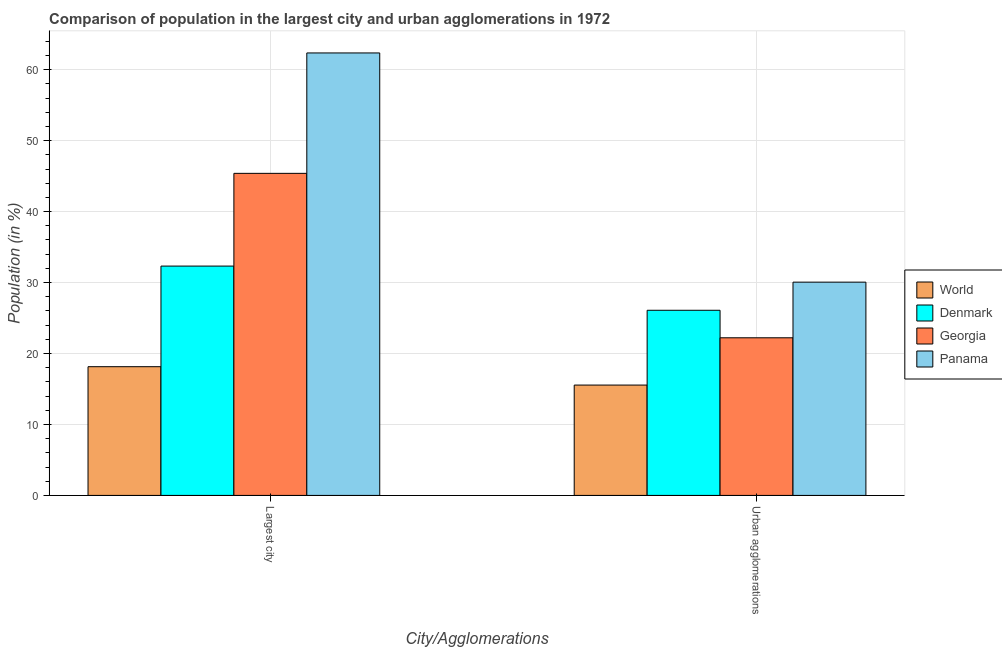How many different coloured bars are there?
Make the answer very short. 4. Are the number of bars on each tick of the X-axis equal?
Keep it short and to the point. Yes. How many bars are there on the 2nd tick from the left?
Offer a terse response. 4. What is the label of the 2nd group of bars from the left?
Your answer should be very brief. Urban agglomerations. What is the population in urban agglomerations in Denmark?
Keep it short and to the point. 26.09. Across all countries, what is the maximum population in the largest city?
Offer a very short reply. 62.36. Across all countries, what is the minimum population in urban agglomerations?
Provide a succinct answer. 15.55. In which country was the population in the largest city maximum?
Keep it short and to the point. Panama. In which country was the population in urban agglomerations minimum?
Give a very brief answer. World. What is the total population in urban agglomerations in the graph?
Your response must be concise. 93.92. What is the difference between the population in the largest city in Panama and that in World?
Give a very brief answer. 44.22. What is the difference between the population in the largest city in Georgia and the population in urban agglomerations in Panama?
Give a very brief answer. 15.33. What is the average population in the largest city per country?
Offer a very short reply. 39.55. What is the difference between the population in the largest city and population in urban agglomerations in Panama?
Give a very brief answer. 32.3. What is the ratio of the population in urban agglomerations in Panama to that in World?
Your answer should be very brief. 1.93. Is the population in the largest city in Panama less than that in Denmark?
Make the answer very short. No. What does the 3rd bar from the left in Urban agglomerations represents?
Your answer should be very brief. Georgia. What does the 2nd bar from the right in Urban agglomerations represents?
Offer a terse response. Georgia. How many bars are there?
Give a very brief answer. 8. What is the difference between two consecutive major ticks on the Y-axis?
Your answer should be compact. 10. Are the values on the major ticks of Y-axis written in scientific E-notation?
Offer a terse response. No. Does the graph contain any zero values?
Your answer should be compact. No. How many legend labels are there?
Provide a short and direct response. 4. What is the title of the graph?
Provide a short and direct response. Comparison of population in the largest city and urban agglomerations in 1972. Does "Uganda" appear as one of the legend labels in the graph?
Your response must be concise. No. What is the label or title of the X-axis?
Your response must be concise. City/Agglomerations. What is the Population (in %) in World in Largest city?
Ensure brevity in your answer.  18.14. What is the Population (in %) in Denmark in Largest city?
Your response must be concise. 32.32. What is the Population (in %) of Georgia in Largest city?
Your answer should be compact. 45.39. What is the Population (in %) of Panama in Largest city?
Your answer should be compact. 62.36. What is the Population (in %) of World in Urban agglomerations?
Your response must be concise. 15.55. What is the Population (in %) of Denmark in Urban agglomerations?
Your answer should be very brief. 26.09. What is the Population (in %) in Georgia in Urban agglomerations?
Provide a short and direct response. 22.22. What is the Population (in %) in Panama in Urban agglomerations?
Your answer should be compact. 30.06. Across all City/Agglomerations, what is the maximum Population (in %) in World?
Provide a short and direct response. 18.14. Across all City/Agglomerations, what is the maximum Population (in %) in Denmark?
Your answer should be compact. 32.32. Across all City/Agglomerations, what is the maximum Population (in %) of Georgia?
Make the answer very short. 45.39. Across all City/Agglomerations, what is the maximum Population (in %) in Panama?
Offer a very short reply. 62.36. Across all City/Agglomerations, what is the minimum Population (in %) in World?
Keep it short and to the point. 15.55. Across all City/Agglomerations, what is the minimum Population (in %) of Denmark?
Provide a succinct answer. 26.09. Across all City/Agglomerations, what is the minimum Population (in %) in Georgia?
Offer a terse response. 22.22. Across all City/Agglomerations, what is the minimum Population (in %) of Panama?
Your response must be concise. 30.06. What is the total Population (in %) of World in the graph?
Your answer should be very brief. 33.69. What is the total Population (in %) of Denmark in the graph?
Your answer should be very brief. 58.41. What is the total Population (in %) of Georgia in the graph?
Offer a terse response. 67.61. What is the total Population (in %) of Panama in the graph?
Provide a short and direct response. 92.42. What is the difference between the Population (in %) of World in Largest city and that in Urban agglomerations?
Make the answer very short. 2.59. What is the difference between the Population (in %) of Denmark in Largest city and that in Urban agglomerations?
Your answer should be very brief. 6.23. What is the difference between the Population (in %) in Georgia in Largest city and that in Urban agglomerations?
Offer a very short reply. 23.18. What is the difference between the Population (in %) of Panama in Largest city and that in Urban agglomerations?
Ensure brevity in your answer.  32.3. What is the difference between the Population (in %) in World in Largest city and the Population (in %) in Denmark in Urban agglomerations?
Provide a succinct answer. -7.95. What is the difference between the Population (in %) of World in Largest city and the Population (in %) of Georgia in Urban agglomerations?
Offer a very short reply. -4.07. What is the difference between the Population (in %) of World in Largest city and the Population (in %) of Panama in Urban agglomerations?
Your answer should be compact. -11.92. What is the difference between the Population (in %) of Denmark in Largest city and the Population (in %) of Georgia in Urban agglomerations?
Make the answer very short. 10.11. What is the difference between the Population (in %) in Denmark in Largest city and the Population (in %) in Panama in Urban agglomerations?
Provide a short and direct response. 2.26. What is the difference between the Population (in %) in Georgia in Largest city and the Population (in %) in Panama in Urban agglomerations?
Offer a terse response. 15.33. What is the average Population (in %) of World per City/Agglomerations?
Offer a terse response. 16.85. What is the average Population (in %) in Denmark per City/Agglomerations?
Give a very brief answer. 29.21. What is the average Population (in %) in Georgia per City/Agglomerations?
Make the answer very short. 33.8. What is the average Population (in %) in Panama per City/Agglomerations?
Provide a succinct answer. 46.21. What is the difference between the Population (in %) of World and Population (in %) of Denmark in Largest city?
Offer a terse response. -14.18. What is the difference between the Population (in %) in World and Population (in %) in Georgia in Largest city?
Your response must be concise. -27.25. What is the difference between the Population (in %) of World and Population (in %) of Panama in Largest city?
Provide a succinct answer. -44.22. What is the difference between the Population (in %) of Denmark and Population (in %) of Georgia in Largest city?
Offer a very short reply. -13.07. What is the difference between the Population (in %) in Denmark and Population (in %) in Panama in Largest city?
Ensure brevity in your answer.  -30.04. What is the difference between the Population (in %) of Georgia and Population (in %) of Panama in Largest city?
Your response must be concise. -16.97. What is the difference between the Population (in %) in World and Population (in %) in Denmark in Urban agglomerations?
Provide a succinct answer. -10.54. What is the difference between the Population (in %) in World and Population (in %) in Georgia in Urban agglomerations?
Your answer should be very brief. -6.66. What is the difference between the Population (in %) of World and Population (in %) of Panama in Urban agglomerations?
Offer a terse response. -14.5. What is the difference between the Population (in %) in Denmark and Population (in %) in Georgia in Urban agglomerations?
Offer a very short reply. 3.88. What is the difference between the Population (in %) in Denmark and Population (in %) in Panama in Urban agglomerations?
Ensure brevity in your answer.  -3.96. What is the difference between the Population (in %) in Georgia and Population (in %) in Panama in Urban agglomerations?
Provide a short and direct response. -7.84. What is the ratio of the Population (in %) of World in Largest city to that in Urban agglomerations?
Ensure brevity in your answer.  1.17. What is the ratio of the Population (in %) of Denmark in Largest city to that in Urban agglomerations?
Your response must be concise. 1.24. What is the ratio of the Population (in %) in Georgia in Largest city to that in Urban agglomerations?
Your answer should be very brief. 2.04. What is the ratio of the Population (in %) of Panama in Largest city to that in Urban agglomerations?
Offer a very short reply. 2.07. What is the difference between the highest and the second highest Population (in %) of World?
Provide a short and direct response. 2.59. What is the difference between the highest and the second highest Population (in %) in Denmark?
Provide a succinct answer. 6.23. What is the difference between the highest and the second highest Population (in %) in Georgia?
Give a very brief answer. 23.18. What is the difference between the highest and the second highest Population (in %) of Panama?
Your answer should be compact. 32.3. What is the difference between the highest and the lowest Population (in %) of World?
Offer a terse response. 2.59. What is the difference between the highest and the lowest Population (in %) of Denmark?
Ensure brevity in your answer.  6.23. What is the difference between the highest and the lowest Population (in %) in Georgia?
Make the answer very short. 23.18. What is the difference between the highest and the lowest Population (in %) in Panama?
Your answer should be compact. 32.3. 